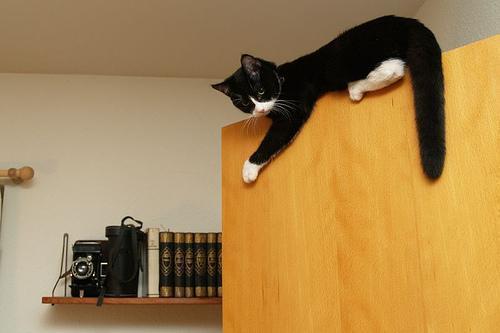What old device can be seen on the left end of the shelf?
Pick the correct solution from the four options below to address the question.
Options: Camera, television, pager, phone. Camera. 